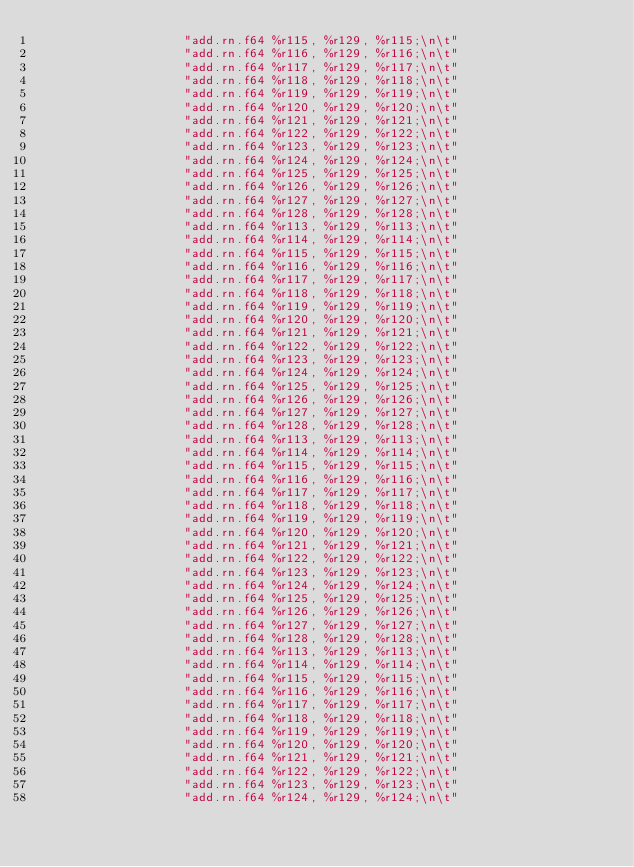Convert code to text. <code><loc_0><loc_0><loc_500><loc_500><_Cuda_>                    "add.rn.f64 %r115, %r129, %r115;\n\t"
                    "add.rn.f64 %r116, %r129, %r116;\n\t"
                    "add.rn.f64 %r117, %r129, %r117;\n\t"
                    "add.rn.f64 %r118, %r129, %r118;\n\t"
                    "add.rn.f64 %r119, %r129, %r119;\n\t"
                    "add.rn.f64 %r120, %r129, %r120;\n\t"
                    "add.rn.f64 %r121, %r129, %r121;\n\t"
                    "add.rn.f64 %r122, %r129, %r122;\n\t"
                    "add.rn.f64 %r123, %r129, %r123;\n\t"
                    "add.rn.f64 %r124, %r129, %r124;\n\t"
                    "add.rn.f64 %r125, %r129, %r125;\n\t"
                    "add.rn.f64 %r126, %r129, %r126;\n\t"
                    "add.rn.f64 %r127, %r129, %r127;\n\t"
                    "add.rn.f64 %r128, %r129, %r128;\n\t"
                    "add.rn.f64 %r113, %r129, %r113;\n\t"
                    "add.rn.f64 %r114, %r129, %r114;\n\t"
                    "add.rn.f64 %r115, %r129, %r115;\n\t"
                    "add.rn.f64 %r116, %r129, %r116;\n\t"
                    "add.rn.f64 %r117, %r129, %r117;\n\t"
                    "add.rn.f64 %r118, %r129, %r118;\n\t"
                    "add.rn.f64 %r119, %r129, %r119;\n\t"
                    "add.rn.f64 %r120, %r129, %r120;\n\t"
                    "add.rn.f64 %r121, %r129, %r121;\n\t"
                    "add.rn.f64 %r122, %r129, %r122;\n\t"
                    "add.rn.f64 %r123, %r129, %r123;\n\t"
                    "add.rn.f64 %r124, %r129, %r124;\n\t"
                    "add.rn.f64 %r125, %r129, %r125;\n\t"
                    "add.rn.f64 %r126, %r129, %r126;\n\t"
                    "add.rn.f64 %r127, %r129, %r127;\n\t"
                    "add.rn.f64 %r128, %r129, %r128;\n\t"
                    "add.rn.f64 %r113, %r129, %r113;\n\t"
                    "add.rn.f64 %r114, %r129, %r114;\n\t"
                    "add.rn.f64 %r115, %r129, %r115;\n\t"
                    "add.rn.f64 %r116, %r129, %r116;\n\t"
                    "add.rn.f64 %r117, %r129, %r117;\n\t"
                    "add.rn.f64 %r118, %r129, %r118;\n\t"
                    "add.rn.f64 %r119, %r129, %r119;\n\t"
                    "add.rn.f64 %r120, %r129, %r120;\n\t"
                    "add.rn.f64 %r121, %r129, %r121;\n\t"
                    "add.rn.f64 %r122, %r129, %r122;\n\t"
                    "add.rn.f64 %r123, %r129, %r123;\n\t"
                    "add.rn.f64 %r124, %r129, %r124;\n\t"
                    "add.rn.f64 %r125, %r129, %r125;\n\t"
                    "add.rn.f64 %r126, %r129, %r126;\n\t"
                    "add.rn.f64 %r127, %r129, %r127;\n\t"
                    "add.rn.f64 %r128, %r129, %r128;\n\t"
                    "add.rn.f64 %r113, %r129, %r113;\n\t"
                    "add.rn.f64 %r114, %r129, %r114;\n\t"
                    "add.rn.f64 %r115, %r129, %r115;\n\t"
                    "add.rn.f64 %r116, %r129, %r116;\n\t"
                    "add.rn.f64 %r117, %r129, %r117;\n\t"
                    "add.rn.f64 %r118, %r129, %r118;\n\t"
                    "add.rn.f64 %r119, %r129, %r119;\n\t"
                    "add.rn.f64 %r120, %r129, %r120;\n\t"
                    "add.rn.f64 %r121, %r129, %r121;\n\t"
                    "add.rn.f64 %r122, %r129, %r122;\n\t"
                    "add.rn.f64 %r123, %r129, %r123;\n\t"
                    "add.rn.f64 %r124, %r129, %r124;\n\t"</code> 